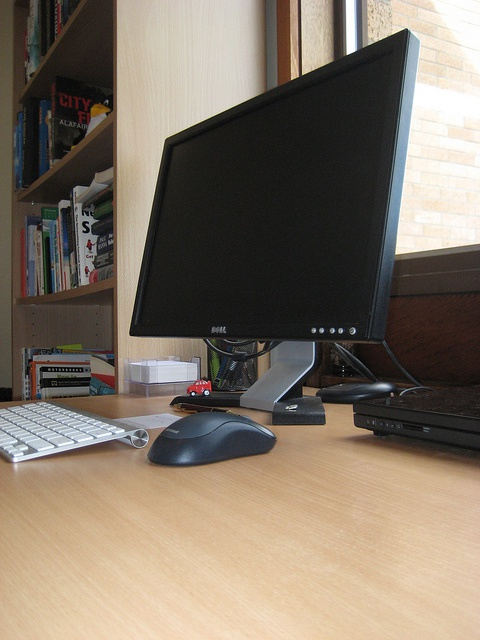Describe the objects in this image and their specific colors. I can see tv in maroon, black, gray, and darkgray tones, laptop in maroon, black, and gray tones, keyboard in maroon, darkgray, lightgray, and gray tones, mouse in maroon, black, gray, and darkblue tones, and book in maroon, black, and gray tones in this image. 